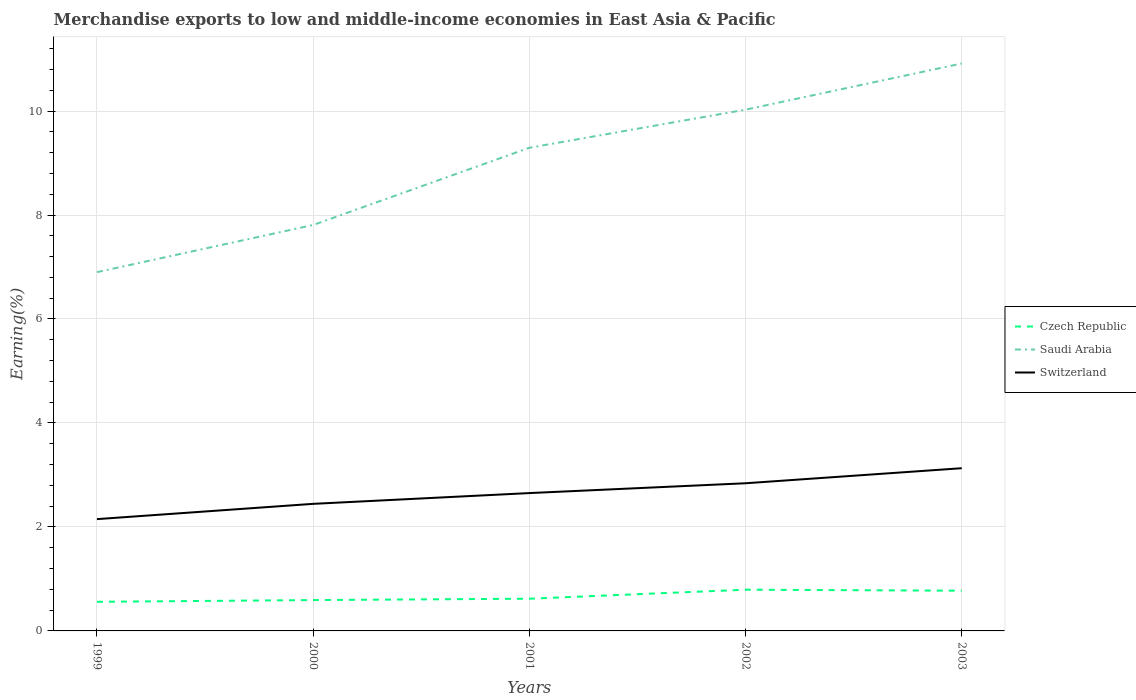How many different coloured lines are there?
Provide a succinct answer. 3. Across all years, what is the maximum percentage of amount earned from merchandise exports in Switzerland?
Offer a very short reply. 2.15. In which year was the percentage of amount earned from merchandise exports in Switzerland maximum?
Your answer should be very brief. 1999. What is the total percentage of amount earned from merchandise exports in Czech Republic in the graph?
Provide a short and direct response. -0.06. What is the difference between the highest and the second highest percentage of amount earned from merchandise exports in Saudi Arabia?
Give a very brief answer. 4.01. Is the percentage of amount earned from merchandise exports in Saudi Arabia strictly greater than the percentage of amount earned from merchandise exports in Czech Republic over the years?
Your response must be concise. No. How many lines are there?
Give a very brief answer. 3. What is the difference between two consecutive major ticks on the Y-axis?
Ensure brevity in your answer.  2. Are the values on the major ticks of Y-axis written in scientific E-notation?
Offer a terse response. No. Does the graph contain any zero values?
Your response must be concise. No. Does the graph contain grids?
Give a very brief answer. Yes. Where does the legend appear in the graph?
Make the answer very short. Center right. How many legend labels are there?
Give a very brief answer. 3. What is the title of the graph?
Your answer should be compact. Merchandise exports to low and middle-income economies in East Asia & Pacific. What is the label or title of the Y-axis?
Offer a terse response. Earning(%). What is the Earning(%) of Czech Republic in 1999?
Offer a terse response. 0.56. What is the Earning(%) of Saudi Arabia in 1999?
Give a very brief answer. 6.9. What is the Earning(%) in Switzerland in 1999?
Offer a very short reply. 2.15. What is the Earning(%) of Czech Republic in 2000?
Ensure brevity in your answer.  0.59. What is the Earning(%) in Saudi Arabia in 2000?
Make the answer very short. 7.81. What is the Earning(%) of Switzerland in 2000?
Your answer should be compact. 2.44. What is the Earning(%) in Czech Republic in 2001?
Offer a terse response. 0.62. What is the Earning(%) of Saudi Arabia in 2001?
Offer a very short reply. 9.29. What is the Earning(%) of Switzerland in 2001?
Provide a succinct answer. 2.65. What is the Earning(%) in Czech Republic in 2002?
Make the answer very short. 0.79. What is the Earning(%) in Saudi Arabia in 2002?
Ensure brevity in your answer.  10.03. What is the Earning(%) of Switzerland in 2002?
Keep it short and to the point. 2.84. What is the Earning(%) in Czech Republic in 2003?
Ensure brevity in your answer.  0.77. What is the Earning(%) of Saudi Arabia in 2003?
Offer a terse response. 10.91. What is the Earning(%) of Switzerland in 2003?
Give a very brief answer. 3.13. Across all years, what is the maximum Earning(%) in Czech Republic?
Keep it short and to the point. 0.79. Across all years, what is the maximum Earning(%) of Saudi Arabia?
Offer a very short reply. 10.91. Across all years, what is the maximum Earning(%) of Switzerland?
Your response must be concise. 3.13. Across all years, what is the minimum Earning(%) in Czech Republic?
Provide a short and direct response. 0.56. Across all years, what is the minimum Earning(%) of Saudi Arabia?
Offer a terse response. 6.9. Across all years, what is the minimum Earning(%) in Switzerland?
Your answer should be very brief. 2.15. What is the total Earning(%) of Czech Republic in the graph?
Provide a succinct answer. 3.34. What is the total Earning(%) in Saudi Arabia in the graph?
Offer a very short reply. 44.94. What is the total Earning(%) in Switzerland in the graph?
Offer a terse response. 13.22. What is the difference between the Earning(%) in Czech Republic in 1999 and that in 2000?
Make the answer very short. -0.03. What is the difference between the Earning(%) in Saudi Arabia in 1999 and that in 2000?
Your response must be concise. -0.91. What is the difference between the Earning(%) in Switzerland in 1999 and that in 2000?
Offer a terse response. -0.29. What is the difference between the Earning(%) of Czech Republic in 1999 and that in 2001?
Your response must be concise. -0.06. What is the difference between the Earning(%) of Saudi Arabia in 1999 and that in 2001?
Your answer should be very brief. -2.39. What is the difference between the Earning(%) of Switzerland in 1999 and that in 2001?
Ensure brevity in your answer.  -0.5. What is the difference between the Earning(%) in Czech Republic in 1999 and that in 2002?
Provide a succinct answer. -0.23. What is the difference between the Earning(%) in Saudi Arabia in 1999 and that in 2002?
Your answer should be very brief. -3.12. What is the difference between the Earning(%) in Switzerland in 1999 and that in 2002?
Keep it short and to the point. -0.69. What is the difference between the Earning(%) in Czech Republic in 1999 and that in 2003?
Ensure brevity in your answer.  -0.21. What is the difference between the Earning(%) of Saudi Arabia in 1999 and that in 2003?
Provide a short and direct response. -4.01. What is the difference between the Earning(%) of Switzerland in 1999 and that in 2003?
Offer a terse response. -0.98. What is the difference between the Earning(%) of Czech Republic in 2000 and that in 2001?
Provide a short and direct response. -0.03. What is the difference between the Earning(%) in Saudi Arabia in 2000 and that in 2001?
Offer a very short reply. -1.49. What is the difference between the Earning(%) of Switzerland in 2000 and that in 2001?
Offer a terse response. -0.21. What is the difference between the Earning(%) in Czech Republic in 2000 and that in 2002?
Make the answer very short. -0.2. What is the difference between the Earning(%) of Saudi Arabia in 2000 and that in 2002?
Provide a succinct answer. -2.22. What is the difference between the Earning(%) in Switzerland in 2000 and that in 2002?
Make the answer very short. -0.4. What is the difference between the Earning(%) of Czech Republic in 2000 and that in 2003?
Your answer should be compact. -0.18. What is the difference between the Earning(%) in Saudi Arabia in 2000 and that in 2003?
Offer a terse response. -3.11. What is the difference between the Earning(%) of Switzerland in 2000 and that in 2003?
Provide a succinct answer. -0.69. What is the difference between the Earning(%) in Czech Republic in 2001 and that in 2002?
Offer a very short reply. -0.17. What is the difference between the Earning(%) in Saudi Arabia in 2001 and that in 2002?
Provide a succinct answer. -0.73. What is the difference between the Earning(%) of Switzerland in 2001 and that in 2002?
Your response must be concise. -0.19. What is the difference between the Earning(%) of Czech Republic in 2001 and that in 2003?
Offer a very short reply. -0.15. What is the difference between the Earning(%) of Saudi Arabia in 2001 and that in 2003?
Provide a succinct answer. -1.62. What is the difference between the Earning(%) of Switzerland in 2001 and that in 2003?
Give a very brief answer. -0.48. What is the difference between the Earning(%) in Czech Republic in 2002 and that in 2003?
Give a very brief answer. 0.02. What is the difference between the Earning(%) of Saudi Arabia in 2002 and that in 2003?
Keep it short and to the point. -0.89. What is the difference between the Earning(%) in Switzerland in 2002 and that in 2003?
Offer a very short reply. -0.29. What is the difference between the Earning(%) in Czech Republic in 1999 and the Earning(%) in Saudi Arabia in 2000?
Offer a terse response. -7.25. What is the difference between the Earning(%) in Czech Republic in 1999 and the Earning(%) in Switzerland in 2000?
Your response must be concise. -1.88. What is the difference between the Earning(%) of Saudi Arabia in 1999 and the Earning(%) of Switzerland in 2000?
Your response must be concise. 4.46. What is the difference between the Earning(%) in Czech Republic in 1999 and the Earning(%) in Saudi Arabia in 2001?
Keep it short and to the point. -8.73. What is the difference between the Earning(%) of Czech Republic in 1999 and the Earning(%) of Switzerland in 2001?
Provide a short and direct response. -2.09. What is the difference between the Earning(%) of Saudi Arabia in 1999 and the Earning(%) of Switzerland in 2001?
Your answer should be compact. 4.25. What is the difference between the Earning(%) of Czech Republic in 1999 and the Earning(%) of Saudi Arabia in 2002?
Give a very brief answer. -9.47. What is the difference between the Earning(%) in Czech Republic in 1999 and the Earning(%) in Switzerland in 2002?
Offer a terse response. -2.28. What is the difference between the Earning(%) of Saudi Arabia in 1999 and the Earning(%) of Switzerland in 2002?
Offer a terse response. 4.06. What is the difference between the Earning(%) of Czech Republic in 1999 and the Earning(%) of Saudi Arabia in 2003?
Offer a very short reply. -10.35. What is the difference between the Earning(%) of Czech Republic in 1999 and the Earning(%) of Switzerland in 2003?
Make the answer very short. -2.57. What is the difference between the Earning(%) in Saudi Arabia in 1999 and the Earning(%) in Switzerland in 2003?
Offer a very short reply. 3.77. What is the difference between the Earning(%) of Czech Republic in 2000 and the Earning(%) of Saudi Arabia in 2001?
Give a very brief answer. -8.7. What is the difference between the Earning(%) of Czech Republic in 2000 and the Earning(%) of Switzerland in 2001?
Provide a succinct answer. -2.06. What is the difference between the Earning(%) of Saudi Arabia in 2000 and the Earning(%) of Switzerland in 2001?
Offer a very short reply. 5.16. What is the difference between the Earning(%) in Czech Republic in 2000 and the Earning(%) in Saudi Arabia in 2002?
Ensure brevity in your answer.  -9.43. What is the difference between the Earning(%) of Czech Republic in 2000 and the Earning(%) of Switzerland in 2002?
Provide a short and direct response. -2.25. What is the difference between the Earning(%) of Saudi Arabia in 2000 and the Earning(%) of Switzerland in 2002?
Your response must be concise. 4.97. What is the difference between the Earning(%) of Czech Republic in 2000 and the Earning(%) of Saudi Arabia in 2003?
Your answer should be compact. -10.32. What is the difference between the Earning(%) of Czech Republic in 2000 and the Earning(%) of Switzerland in 2003?
Offer a very short reply. -2.54. What is the difference between the Earning(%) of Saudi Arabia in 2000 and the Earning(%) of Switzerland in 2003?
Provide a succinct answer. 4.68. What is the difference between the Earning(%) in Czech Republic in 2001 and the Earning(%) in Saudi Arabia in 2002?
Offer a terse response. -9.41. What is the difference between the Earning(%) in Czech Republic in 2001 and the Earning(%) in Switzerland in 2002?
Keep it short and to the point. -2.22. What is the difference between the Earning(%) in Saudi Arabia in 2001 and the Earning(%) in Switzerland in 2002?
Ensure brevity in your answer.  6.45. What is the difference between the Earning(%) of Czech Republic in 2001 and the Earning(%) of Saudi Arabia in 2003?
Your answer should be very brief. -10.29. What is the difference between the Earning(%) in Czech Republic in 2001 and the Earning(%) in Switzerland in 2003?
Offer a very short reply. -2.51. What is the difference between the Earning(%) of Saudi Arabia in 2001 and the Earning(%) of Switzerland in 2003?
Give a very brief answer. 6.16. What is the difference between the Earning(%) of Czech Republic in 2002 and the Earning(%) of Saudi Arabia in 2003?
Offer a very short reply. -10.12. What is the difference between the Earning(%) of Czech Republic in 2002 and the Earning(%) of Switzerland in 2003?
Offer a terse response. -2.34. What is the difference between the Earning(%) in Saudi Arabia in 2002 and the Earning(%) in Switzerland in 2003?
Offer a very short reply. 6.9. What is the average Earning(%) in Czech Republic per year?
Offer a terse response. 0.67. What is the average Earning(%) in Saudi Arabia per year?
Make the answer very short. 8.99. What is the average Earning(%) of Switzerland per year?
Make the answer very short. 2.64. In the year 1999, what is the difference between the Earning(%) in Czech Republic and Earning(%) in Saudi Arabia?
Make the answer very short. -6.34. In the year 1999, what is the difference between the Earning(%) in Czech Republic and Earning(%) in Switzerland?
Ensure brevity in your answer.  -1.59. In the year 1999, what is the difference between the Earning(%) of Saudi Arabia and Earning(%) of Switzerland?
Provide a succinct answer. 4.75. In the year 2000, what is the difference between the Earning(%) in Czech Republic and Earning(%) in Saudi Arabia?
Ensure brevity in your answer.  -7.21. In the year 2000, what is the difference between the Earning(%) in Czech Republic and Earning(%) in Switzerland?
Your response must be concise. -1.85. In the year 2000, what is the difference between the Earning(%) of Saudi Arabia and Earning(%) of Switzerland?
Give a very brief answer. 5.36. In the year 2001, what is the difference between the Earning(%) in Czech Republic and Earning(%) in Saudi Arabia?
Give a very brief answer. -8.67. In the year 2001, what is the difference between the Earning(%) in Czech Republic and Earning(%) in Switzerland?
Keep it short and to the point. -2.03. In the year 2001, what is the difference between the Earning(%) of Saudi Arabia and Earning(%) of Switzerland?
Make the answer very short. 6.64. In the year 2002, what is the difference between the Earning(%) of Czech Republic and Earning(%) of Saudi Arabia?
Ensure brevity in your answer.  -9.23. In the year 2002, what is the difference between the Earning(%) in Czech Republic and Earning(%) in Switzerland?
Offer a terse response. -2.05. In the year 2002, what is the difference between the Earning(%) in Saudi Arabia and Earning(%) in Switzerland?
Give a very brief answer. 7.19. In the year 2003, what is the difference between the Earning(%) in Czech Republic and Earning(%) in Saudi Arabia?
Your answer should be very brief. -10.14. In the year 2003, what is the difference between the Earning(%) in Czech Republic and Earning(%) in Switzerland?
Your response must be concise. -2.36. In the year 2003, what is the difference between the Earning(%) of Saudi Arabia and Earning(%) of Switzerland?
Ensure brevity in your answer.  7.78. What is the ratio of the Earning(%) in Czech Republic in 1999 to that in 2000?
Provide a succinct answer. 0.94. What is the ratio of the Earning(%) in Saudi Arabia in 1999 to that in 2000?
Your answer should be very brief. 0.88. What is the ratio of the Earning(%) in Switzerland in 1999 to that in 2000?
Ensure brevity in your answer.  0.88. What is the ratio of the Earning(%) of Czech Republic in 1999 to that in 2001?
Give a very brief answer. 0.9. What is the ratio of the Earning(%) in Saudi Arabia in 1999 to that in 2001?
Offer a terse response. 0.74. What is the ratio of the Earning(%) in Switzerland in 1999 to that in 2001?
Offer a terse response. 0.81. What is the ratio of the Earning(%) in Czech Republic in 1999 to that in 2002?
Provide a succinct answer. 0.71. What is the ratio of the Earning(%) in Saudi Arabia in 1999 to that in 2002?
Ensure brevity in your answer.  0.69. What is the ratio of the Earning(%) of Switzerland in 1999 to that in 2002?
Make the answer very short. 0.76. What is the ratio of the Earning(%) in Czech Republic in 1999 to that in 2003?
Offer a very short reply. 0.72. What is the ratio of the Earning(%) in Saudi Arabia in 1999 to that in 2003?
Your response must be concise. 0.63. What is the ratio of the Earning(%) in Switzerland in 1999 to that in 2003?
Your response must be concise. 0.69. What is the ratio of the Earning(%) of Czech Republic in 2000 to that in 2001?
Offer a very short reply. 0.96. What is the ratio of the Earning(%) of Saudi Arabia in 2000 to that in 2001?
Provide a succinct answer. 0.84. What is the ratio of the Earning(%) in Switzerland in 2000 to that in 2001?
Keep it short and to the point. 0.92. What is the ratio of the Earning(%) of Czech Republic in 2000 to that in 2002?
Keep it short and to the point. 0.75. What is the ratio of the Earning(%) of Saudi Arabia in 2000 to that in 2002?
Offer a terse response. 0.78. What is the ratio of the Earning(%) in Switzerland in 2000 to that in 2002?
Your answer should be compact. 0.86. What is the ratio of the Earning(%) of Czech Republic in 2000 to that in 2003?
Give a very brief answer. 0.77. What is the ratio of the Earning(%) in Saudi Arabia in 2000 to that in 2003?
Your answer should be compact. 0.72. What is the ratio of the Earning(%) in Switzerland in 2000 to that in 2003?
Keep it short and to the point. 0.78. What is the ratio of the Earning(%) in Czech Republic in 2001 to that in 2002?
Your answer should be very brief. 0.78. What is the ratio of the Earning(%) in Saudi Arabia in 2001 to that in 2002?
Give a very brief answer. 0.93. What is the ratio of the Earning(%) in Switzerland in 2001 to that in 2002?
Give a very brief answer. 0.93. What is the ratio of the Earning(%) of Czech Republic in 2001 to that in 2003?
Your answer should be compact. 0.8. What is the ratio of the Earning(%) in Saudi Arabia in 2001 to that in 2003?
Provide a succinct answer. 0.85. What is the ratio of the Earning(%) of Switzerland in 2001 to that in 2003?
Offer a very short reply. 0.85. What is the ratio of the Earning(%) of Czech Republic in 2002 to that in 2003?
Make the answer very short. 1.02. What is the ratio of the Earning(%) of Saudi Arabia in 2002 to that in 2003?
Make the answer very short. 0.92. What is the ratio of the Earning(%) in Switzerland in 2002 to that in 2003?
Make the answer very short. 0.91. What is the difference between the highest and the second highest Earning(%) in Czech Republic?
Offer a very short reply. 0.02. What is the difference between the highest and the second highest Earning(%) of Saudi Arabia?
Provide a succinct answer. 0.89. What is the difference between the highest and the second highest Earning(%) in Switzerland?
Keep it short and to the point. 0.29. What is the difference between the highest and the lowest Earning(%) in Czech Republic?
Make the answer very short. 0.23. What is the difference between the highest and the lowest Earning(%) in Saudi Arabia?
Provide a short and direct response. 4.01. What is the difference between the highest and the lowest Earning(%) in Switzerland?
Give a very brief answer. 0.98. 